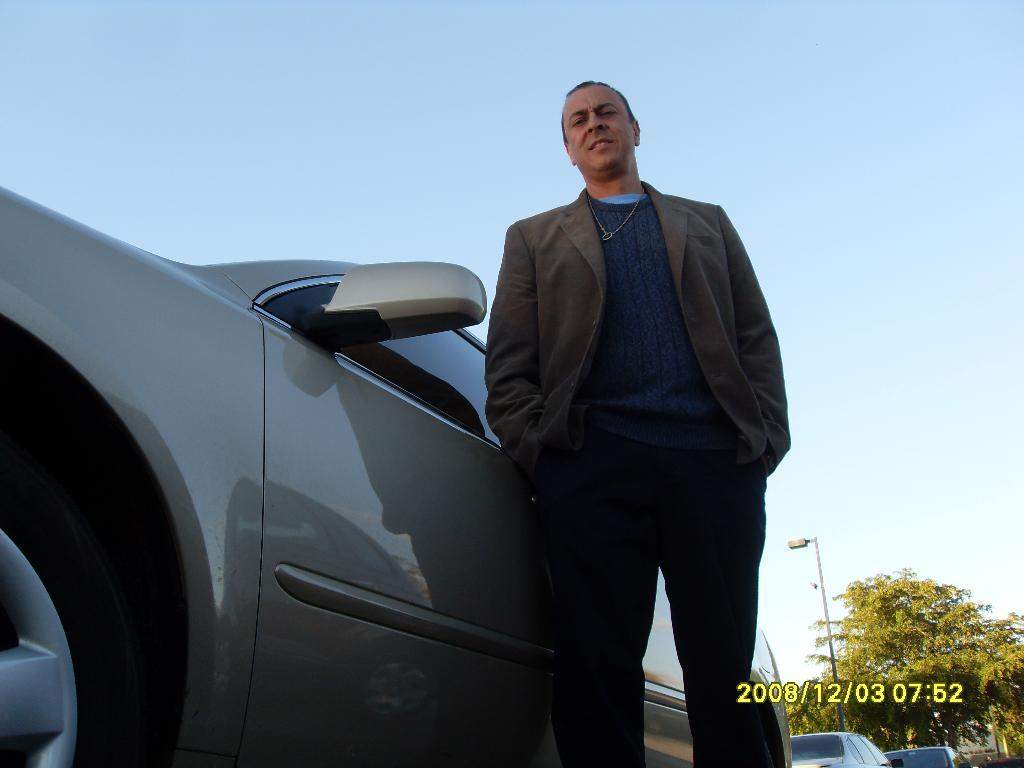Who is present in the image? There is a man in the image. What type of vehicles can be seen in the image? There are cars in the image. What object is present in the image that is used for support or guidance? There is a pole in the image. What is the source of illumination in the image? There is a light in the image. What type of natural vegetation is visible in the image? There are trees in the image. What part of the natural environment is visible in the background of the image? The sky is visible in the background of the image. What text can be found at the bottom of the image? There is text written at the bottom of the image. What type of clam is being served at the restaurant in the image? There is no restaurant or clam present in the image. What type of minister is depicted in the image? There is no minister present in the image. 